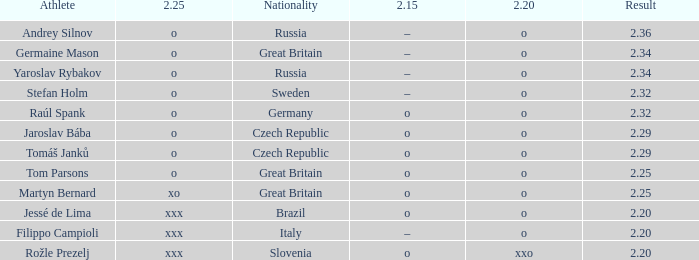What is the 2.15 for Tom Parsons? O. 